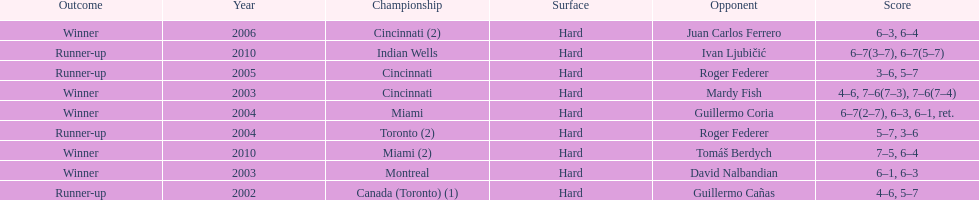How many consecutive years was there a hard surface at the championship? 9. Write the full table. {'header': ['Outcome', 'Year', 'Championship', 'Surface', 'Opponent', 'Score'], 'rows': [['Winner', '2006', 'Cincinnati (2)', 'Hard', 'Juan Carlos Ferrero', '6–3, 6–4'], ['Runner-up', '2010', 'Indian Wells', 'Hard', 'Ivan Ljubičić', '6–7(3–7), 6–7(5–7)'], ['Runner-up', '2005', 'Cincinnati', 'Hard', 'Roger Federer', '3–6, 5–7'], ['Winner', '2003', 'Cincinnati', 'Hard', 'Mardy Fish', '4–6, 7–6(7–3), 7–6(7–4)'], ['Winner', '2004', 'Miami', 'Hard', 'Guillermo Coria', '6–7(2–7), 6–3, 6–1, ret.'], ['Runner-up', '2004', 'Toronto (2)', 'Hard', 'Roger Federer', '5–7, 3–6'], ['Winner', '2010', 'Miami (2)', 'Hard', 'Tomáš Berdych', '7–5, 6–4'], ['Winner', '2003', 'Montreal', 'Hard', 'David Nalbandian', '6–1, 6–3'], ['Runner-up', '2002', 'Canada (Toronto) (1)', 'Hard', 'Guillermo Cañas', '4–6, 5–7']]} 